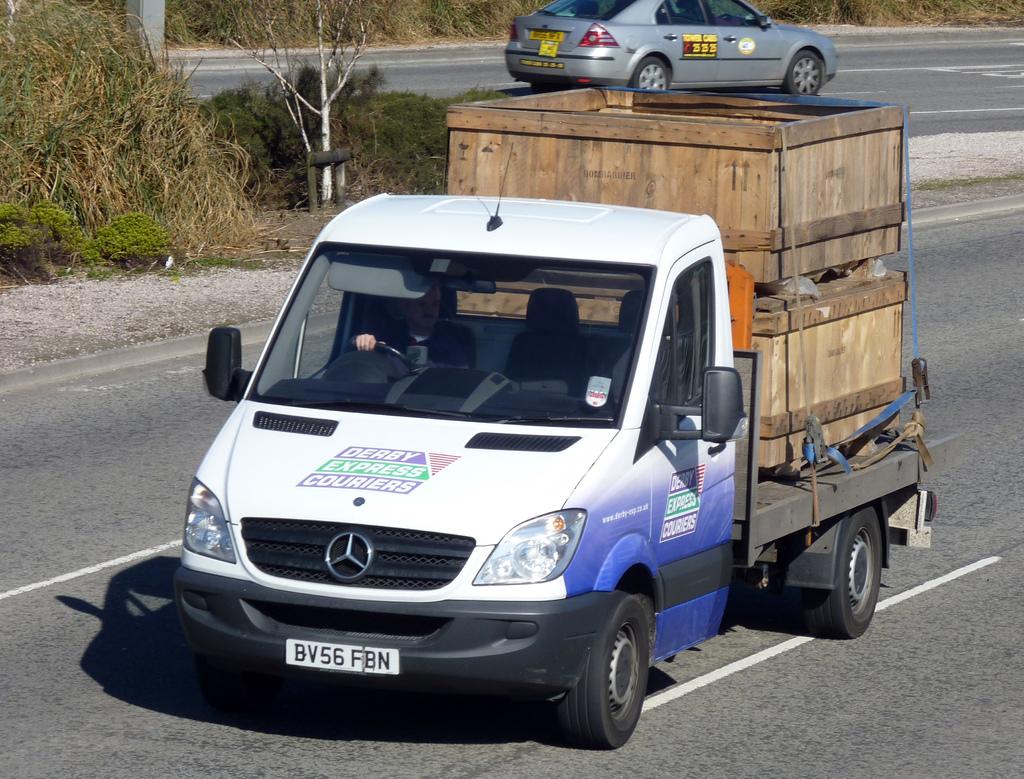What is the license of the truck?
Give a very brief answer. Bv56 fbn. 